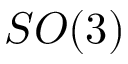<formula> <loc_0><loc_0><loc_500><loc_500>S O ( 3 )</formula> 